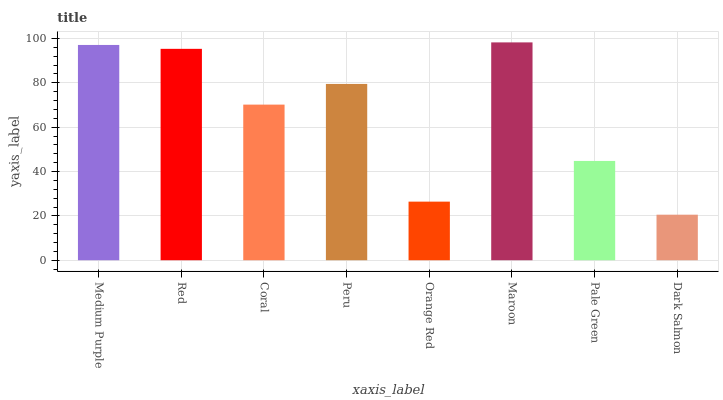Is Dark Salmon the minimum?
Answer yes or no. Yes. Is Maroon the maximum?
Answer yes or no. Yes. Is Red the minimum?
Answer yes or no. No. Is Red the maximum?
Answer yes or no. No. Is Medium Purple greater than Red?
Answer yes or no. Yes. Is Red less than Medium Purple?
Answer yes or no. Yes. Is Red greater than Medium Purple?
Answer yes or no. No. Is Medium Purple less than Red?
Answer yes or no. No. Is Peru the high median?
Answer yes or no. Yes. Is Coral the low median?
Answer yes or no. Yes. Is Medium Purple the high median?
Answer yes or no. No. Is Pale Green the low median?
Answer yes or no. No. 